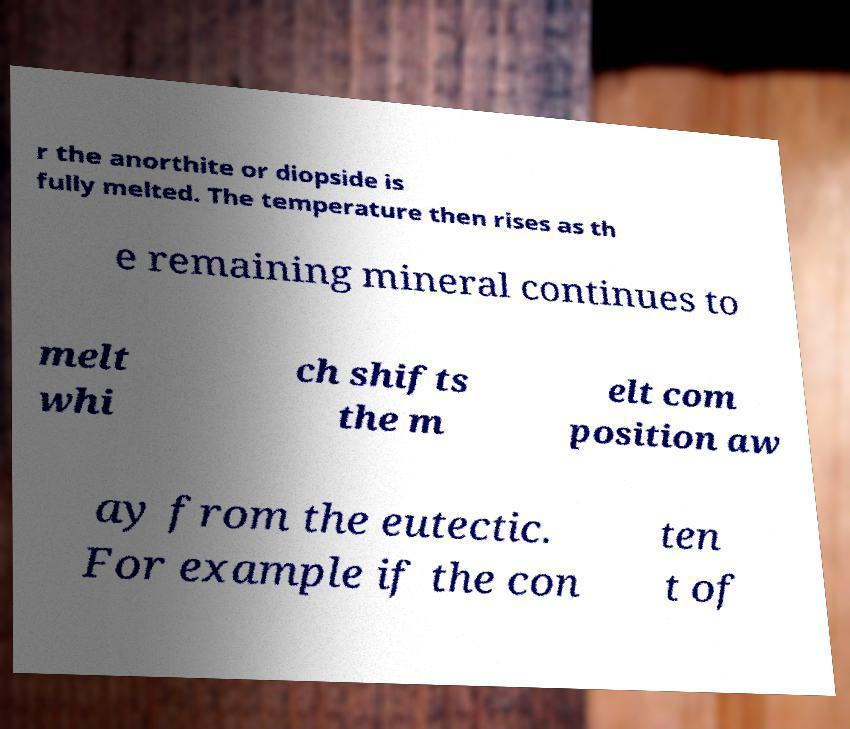There's text embedded in this image that I need extracted. Can you transcribe it verbatim? r the anorthite or diopside is fully melted. The temperature then rises as th e remaining mineral continues to melt whi ch shifts the m elt com position aw ay from the eutectic. For example if the con ten t of 